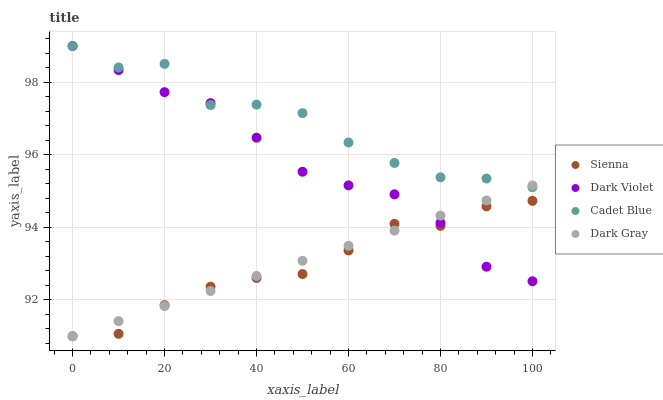Does Sienna have the minimum area under the curve?
Answer yes or no. Yes. Does Cadet Blue have the maximum area under the curve?
Answer yes or no. Yes. Does Dark Gray have the minimum area under the curve?
Answer yes or no. No. Does Dark Gray have the maximum area under the curve?
Answer yes or no. No. Is Dark Gray the smoothest?
Answer yes or no. Yes. Is Cadet Blue the roughest?
Answer yes or no. Yes. Is Cadet Blue the smoothest?
Answer yes or no. No. Is Dark Gray the roughest?
Answer yes or no. No. Does Sienna have the lowest value?
Answer yes or no. Yes. Does Cadet Blue have the lowest value?
Answer yes or no. No. Does Dark Violet have the highest value?
Answer yes or no. Yes. Does Dark Gray have the highest value?
Answer yes or no. No. Is Sienna less than Cadet Blue?
Answer yes or no. Yes. Is Cadet Blue greater than Sienna?
Answer yes or no. Yes. Does Sienna intersect Dark Violet?
Answer yes or no. Yes. Is Sienna less than Dark Violet?
Answer yes or no. No. Is Sienna greater than Dark Violet?
Answer yes or no. No. Does Sienna intersect Cadet Blue?
Answer yes or no. No. 